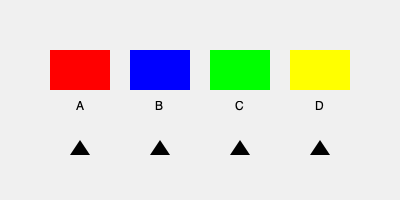In an international cultural exchange exhibition, you need to arrange four country flags (A, B, C, and D) based on their geometric properties. If flag A has a circle, flag B has a triangle, flag C has a square, and flag D has a rectangle, what is the correct order of the flags from left to right if arranged by increasing number of sides? To arrange the flags based on the increasing number of sides in their geometric shapes, we need to follow these steps:

1. Identify the number of sides for each shape:
   - Circle (Flag A): A circle has 0 sides (it's a curved line)
   - Triangle (Flag B): 3 sides
   - Square (Flag C): 4 sides
   - Rectangle (Flag D): 4 sides

2. Order the shapes based on the increasing number of sides:
   - Circle (0 sides)
   - Triangle (3 sides)
   - Square and Rectangle (both 4 sides)

3. Arrange the flags accordingly:
   - Leftmost: Flag A (Circle)
   - Second: Flag B (Triangle)
   - Third and Fourth: Flags C and D (Square and Rectangle)

4. For the last two flags with the same number of sides, we can arrange them alphabetically:
   - Flag C (Square) before Flag D (Rectangle)

Therefore, the correct order from left to right is: A, B, C, D.
Answer: A, B, C, D 